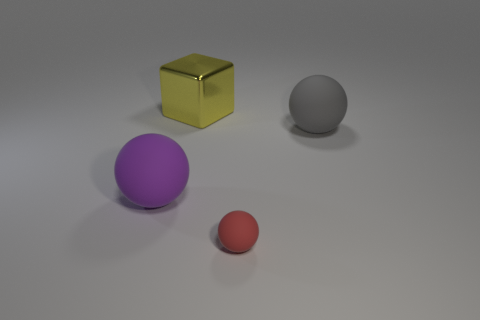The ball in front of the matte object that is to the left of the tiny red thing is made of what material?
Make the answer very short. Rubber. What number of small things are either yellow spheres or yellow shiny objects?
Offer a very short reply. 0. What is the size of the gray matte object?
Offer a terse response. Large. Is the number of purple spheres to the right of the small red sphere greater than the number of things?
Your answer should be compact. No. Are there the same number of purple matte objects that are right of the red rubber sphere and big purple spheres on the right side of the yellow cube?
Your response must be concise. Yes. What color is the object that is both behind the purple thing and to the right of the yellow shiny object?
Give a very brief answer. Gray. Is there anything else that has the same size as the purple ball?
Offer a very short reply. Yes. Is the number of red matte spheres that are behind the red rubber thing greater than the number of balls to the right of the yellow thing?
Your answer should be compact. No. Do the matte sphere left of the red rubber thing and the small matte thing have the same size?
Offer a terse response. No. How many purple matte objects are to the left of the matte thing that is behind the thing that is to the left of the large block?
Give a very brief answer. 1. 